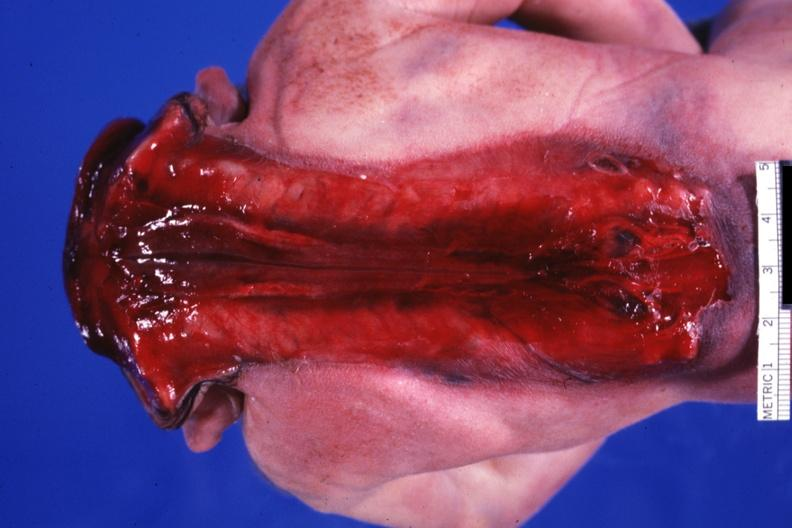what does this image show?
Answer the question using a single word or phrase. Posterior view of whole body to buttocks 